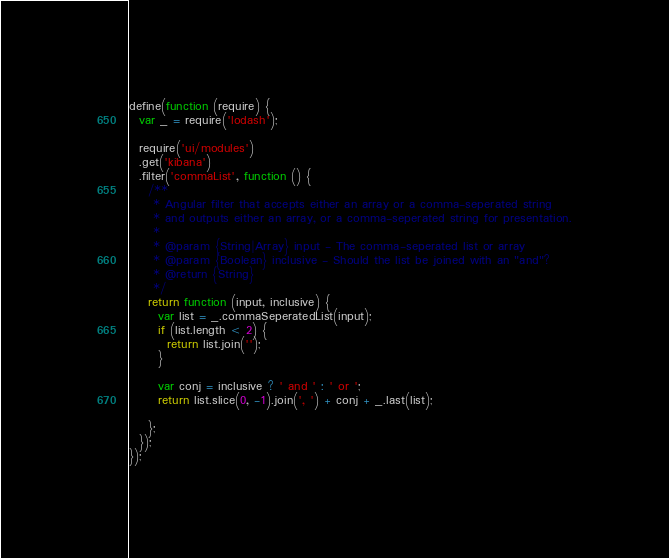Convert code to text. <code><loc_0><loc_0><loc_500><loc_500><_JavaScript_>define(function (require) {
  var _ = require('lodash');

  require('ui/modules')
  .get('kibana')
  .filter('commaList', function () {
    /**
     * Angular filter that accepts either an array or a comma-seperated string
     * and outputs either an array, or a comma-seperated string for presentation.
     *
     * @param {String|Array} input - The comma-seperated list or array
     * @param {Boolean} inclusive - Should the list be joined with an "and"?
     * @return {String}
     */
    return function (input, inclusive) {
      var list = _.commaSeperatedList(input);
      if (list.length < 2) {
        return list.join('');
      }

      var conj = inclusive ? ' and ' : ' or ';
      return list.slice(0, -1).join(', ') + conj + _.last(list);

    };
  });
});
</code> 